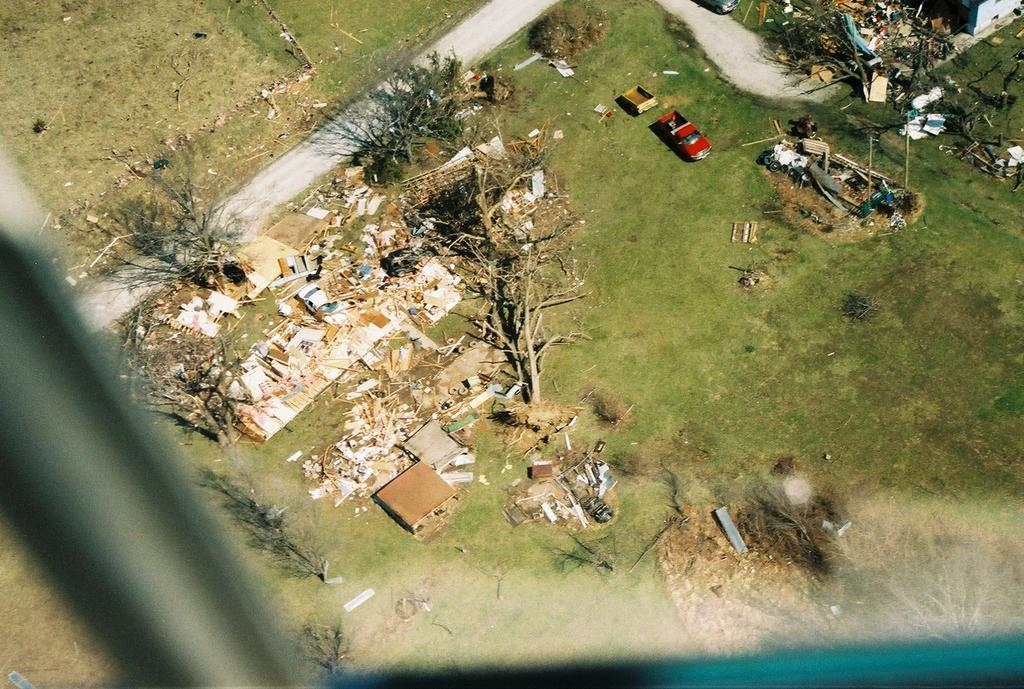What type of vegetation is present in the image? There is grass and trees in the image. What type of man-made object can be seen in the image? There is a car in the image. What type of objects are present in the image that might be used for storage or transportation? There are boxes in the image. Can you describe any other objects in the image that are not specified? There are some unspecified objects in the image. What type of fork can be seen in the image? There is no fork present in the image. What type of art is displayed on the trees in the image? There is no art displayed on the trees in the image. 